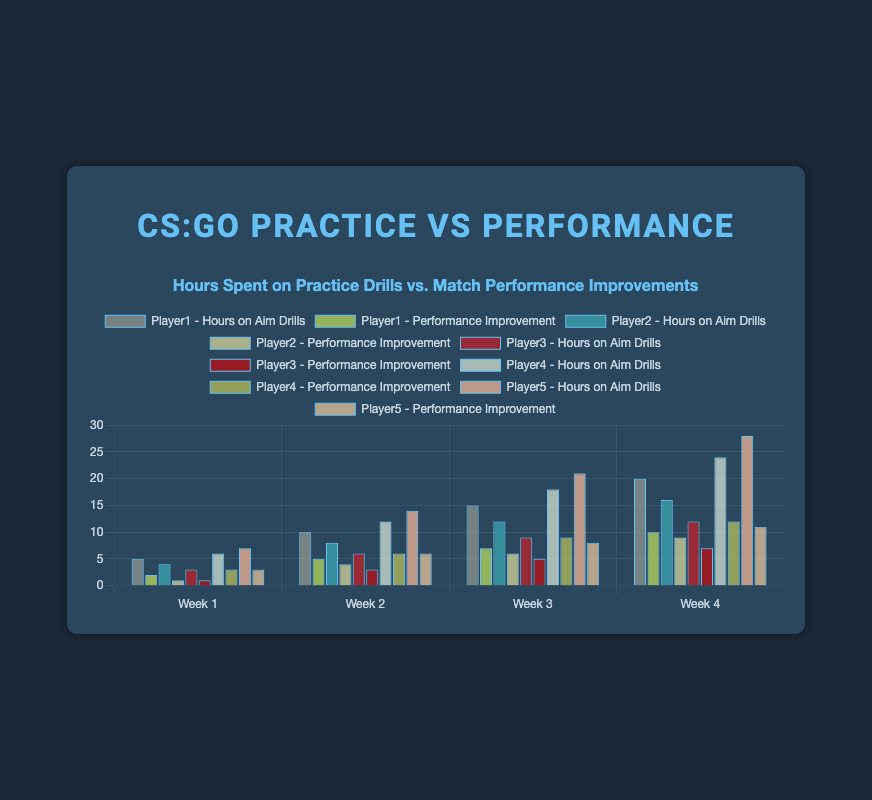Which player spent the most hours on aim drills by Week 4? By looking at the figure, identify the bar representing "Week 4" for each player in the hours on aim drills dataset. Player5 has spent the most hours on aim drills by Week 4 with 28 hours.
Answer: Player5 For Player2, what is the difference in match performance improvement between Week 1 and Week 4? We need to subtract the match performance improvement in Week 1 from that in Week 4 for Player2. The values are 9 (Week 4) and 1 (Week 1), so the difference is 9 - 1 = 8.
Answer: 8 What is the average match performance improvement for Player3 over the four weeks? Add up all match performance improvements for Player3 and divide by the number of weeks (4). They are 1, 3, 5, and 7. The sum is 1+3+5+7=16, and the average is 16/4 = 4.
Answer: 4 Which week shows the highest match performance improvement for Player4? By checking the bars representing each week for Player4 in match performance improvement, Week 4 has the highest value of 12.
Answer: Week 4 How do the hours on aim drills for Player4 in Week 2 compare to those of Player1 in Week 2? Identify and compare the bars for Week 2 for both players. Player4 has 12 hours, whereas Player1 has 10 hours. Player4 spent 2 more hours than Player1 in Week 2.
Answer: Player4 spent 2 more hours Which player has the most consistent improvement in match performance over the four weeks? Look at the bars representing match performance improvement for all weeks per player and check the consistency. Player3 shows a steady increase (1, 3, 5, 7), indicating the most consistent improvement in match performance.
Answer: Player3 How much total time did Player1 and Player3 spend on aim drills by the end of Week 3? Add the hours from Week 1 through Week 3 for both players. Player1: 5 + 10 + 15 = 30 hours; Player3: 3 + 6 + 9 = 18 hours; Total is 30+18 = 48 hours.
Answer: 48 hours Which week demonstrated the greatest overall match performance improvement for Player5? Check each week's bars for Player5's match performance improvement. Week 4 has the highest value of 11, indicating the greatest overall improvement.
Answer: Week 4 Which player's match performance improvement in Week 3 is the closest to Player2's match performance improvement in Week 1? Compare Player2's improvement in Week 1 (1) with other players' values in Week 3. Player3 has an improvement of 5, Player1 has 7, Player4 has 9, and Player5 has 8, so Player2 also in Week 3 with 6 is the closest.
Answer: Player2 